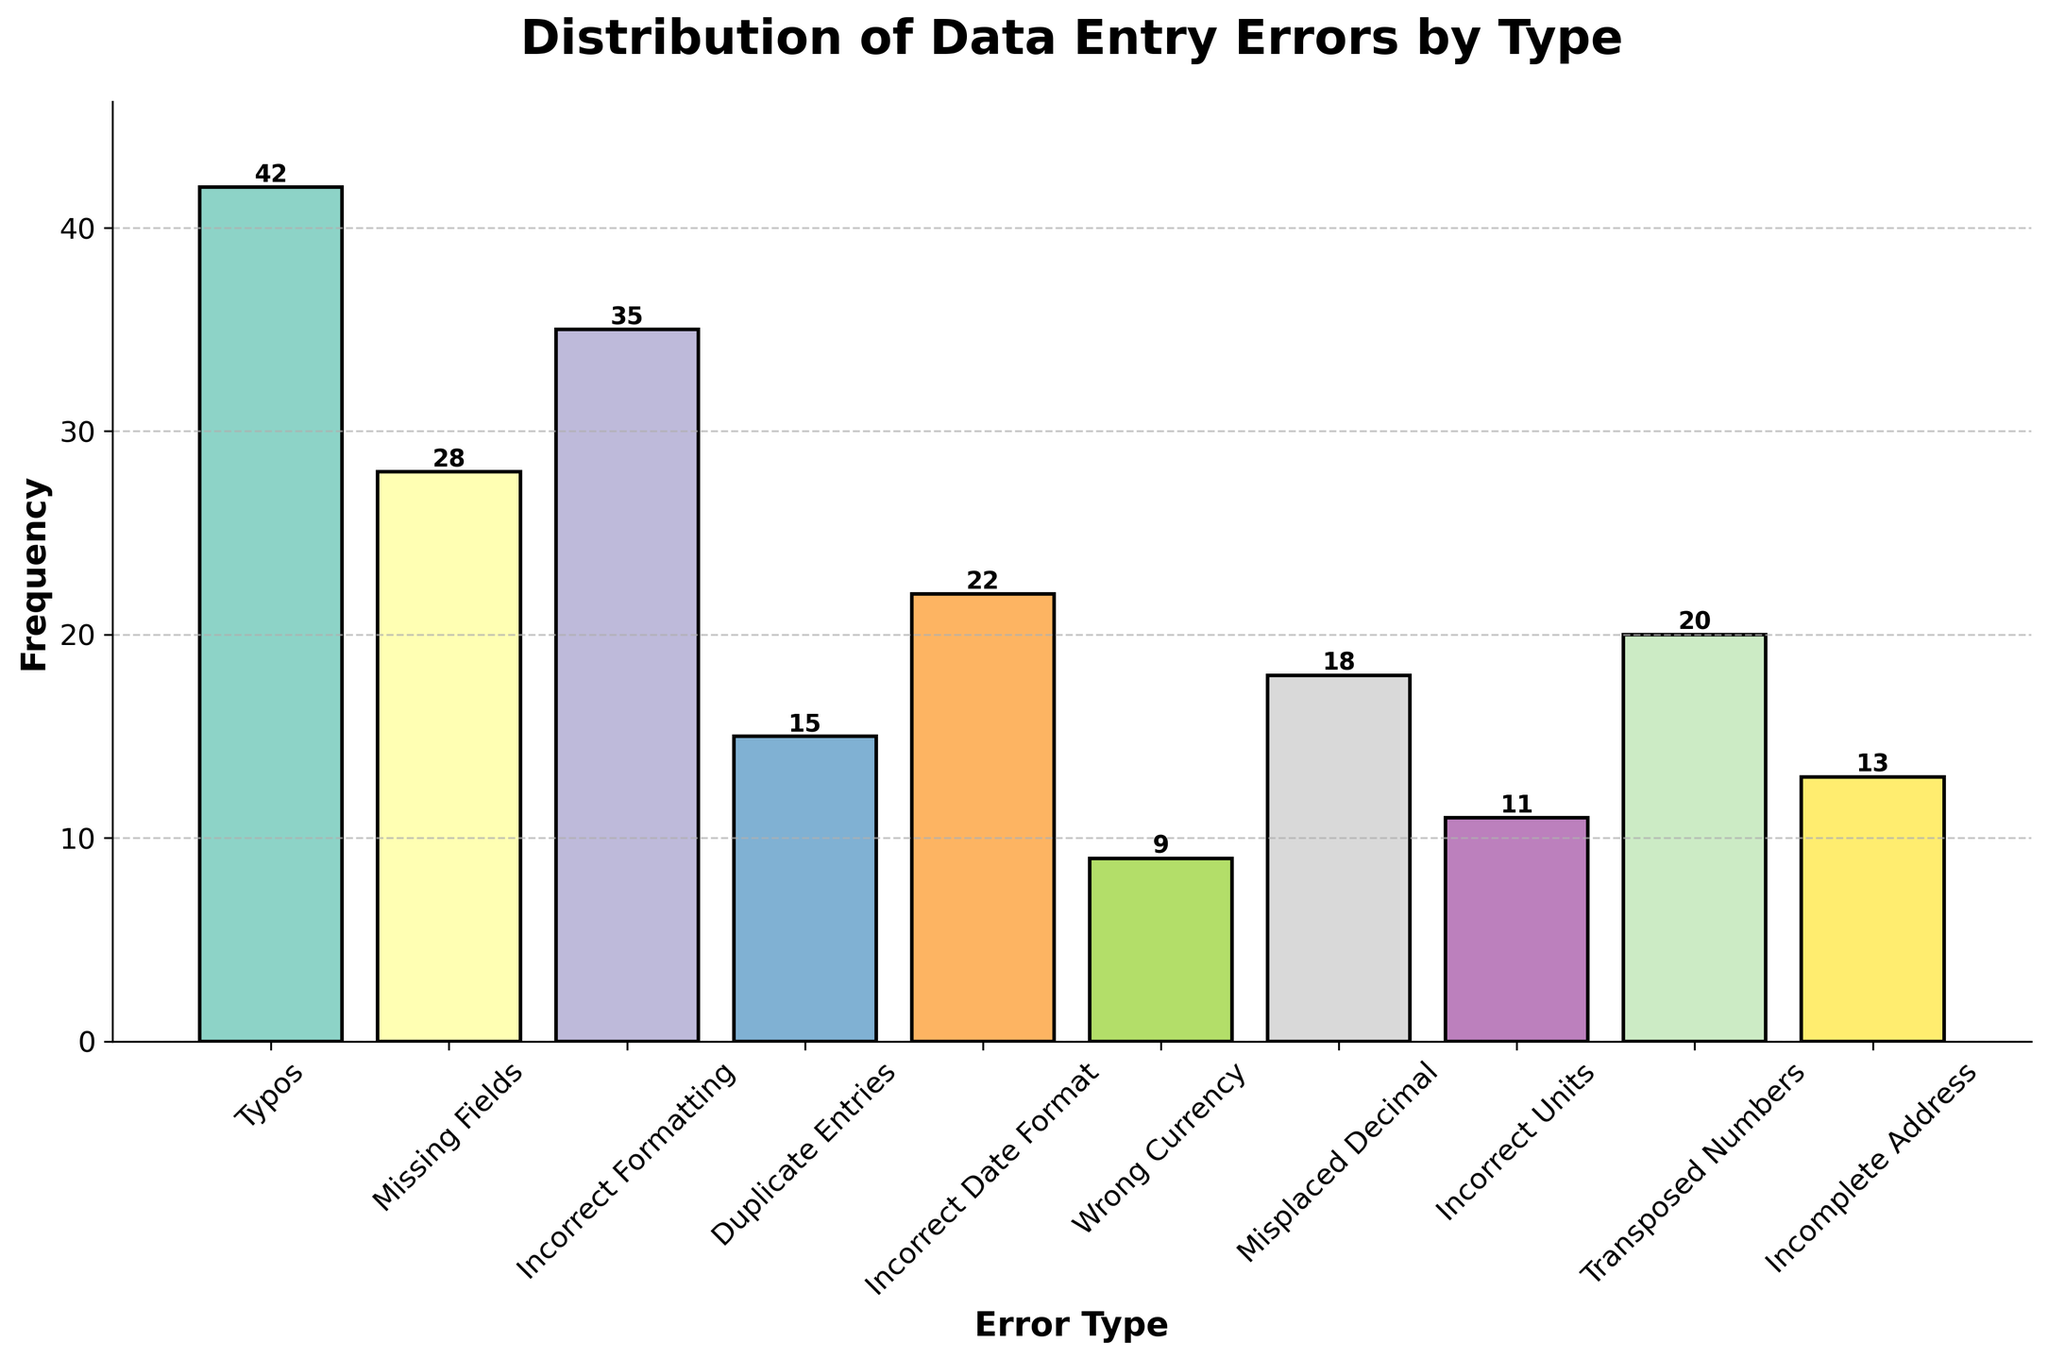What is the most common type of data entry error? To find the most common type of data entry error, look for the bar with the highest frequency. The tallest bar in the histogram represents Typos with a frequency of 42.
Answer: Typos Which error type has a frequency of 28? Look for the bar that reaches up to the tick mark at 28. The Missing Fields error type corresponds to this frequency.
Answer: Missing Fields How many error types have a frequency greater than 20? Count the bars that extend above the 20 mark on the y-axis. There are 4 such bars: Typos, Missing Fields, Incorrect Formatting, and Incorrect Date Format.
Answer: 4 What is the frequency of Incorrect Date Format errors? Locate the bar labeled Incorrect Date Format and check its height. The height is 22.
Answer: 22 How many more Typos are there compared to Duplicate Entries? Check the frequency of Typos (42) and Duplicate Entries (15), then subtract the frequency of Duplicate Entries from Typos. 42 - 15 = 27
Answer: 27 Which type of data entry error has the least frequency? Find the shortest bar in the histogram. The shortest bar corresponds to Wrong Currency with a frequency of 9.
Answer: Wrong Currency What is the total frequency of all data entry errors combined? Sum the frequencies of all error types: 42 + 28 + 35 + 15 + 22 + 9 + 18 + 11 + 20 + 13 = 213
Answer: 213 Are there more instances of Transposed Numbers or Misplaced Decimal? Compare the heights of the bars for Transposed Numbers (20) and Misplaced Decimal (18).
Answer: Transposed Numbers What is the difference in frequency between Incorrect Formatting and Wrong Currency errors? Subtract the frequency of Wrong Currency (9) from Incorrect Formatting (35). 35 - 9 = 26
Answer: 26 What is the average frequency of the error types? Sum all frequencies and divide by the number of error types: (42 + 28 + 35 + 15 + 22 + 9 + 18 + 11 + 20 + 13) / 10 = 213 / 10 = 21.3
Answer: 21.3 